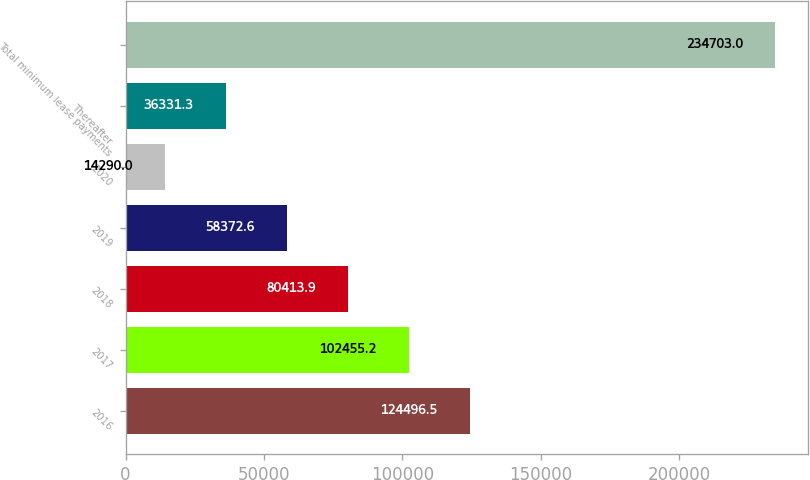Convert chart to OTSL. <chart><loc_0><loc_0><loc_500><loc_500><bar_chart><fcel>2016<fcel>2017<fcel>2018<fcel>2019<fcel>2020<fcel>Thereafter<fcel>Total minimum lease payments<nl><fcel>124496<fcel>102455<fcel>80413.9<fcel>58372.6<fcel>14290<fcel>36331.3<fcel>234703<nl></chart> 